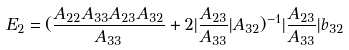<formula> <loc_0><loc_0><loc_500><loc_500>E _ { 2 } = ( \frac { A _ { 2 2 } A _ { 3 3 } A _ { 2 3 } A _ { 3 2 } } { A _ { 3 3 } } + 2 | \frac { A _ { 2 3 } } { A _ { 3 3 } } | A _ { 3 2 } ) ^ { - 1 } | \frac { A _ { 2 3 } } { A _ { 3 3 } } | b _ { 3 2 }</formula> 